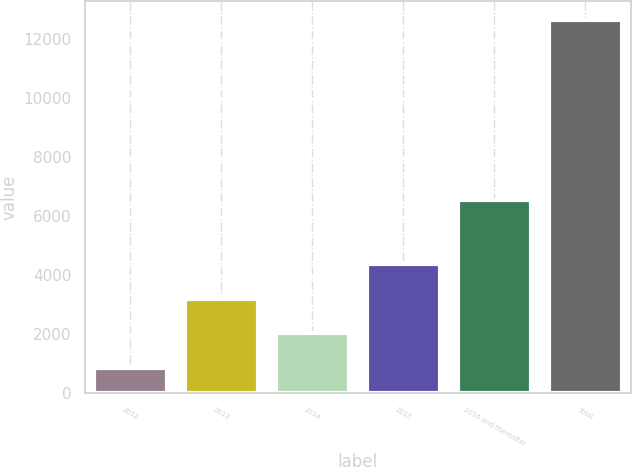<chart> <loc_0><loc_0><loc_500><loc_500><bar_chart><fcel>2012<fcel>2013<fcel>2014<fcel>2015<fcel>2016 and thereafter<fcel>Total<nl><fcel>850<fcel>3210.8<fcel>2030.4<fcel>4391.2<fcel>6554<fcel>12654<nl></chart> 